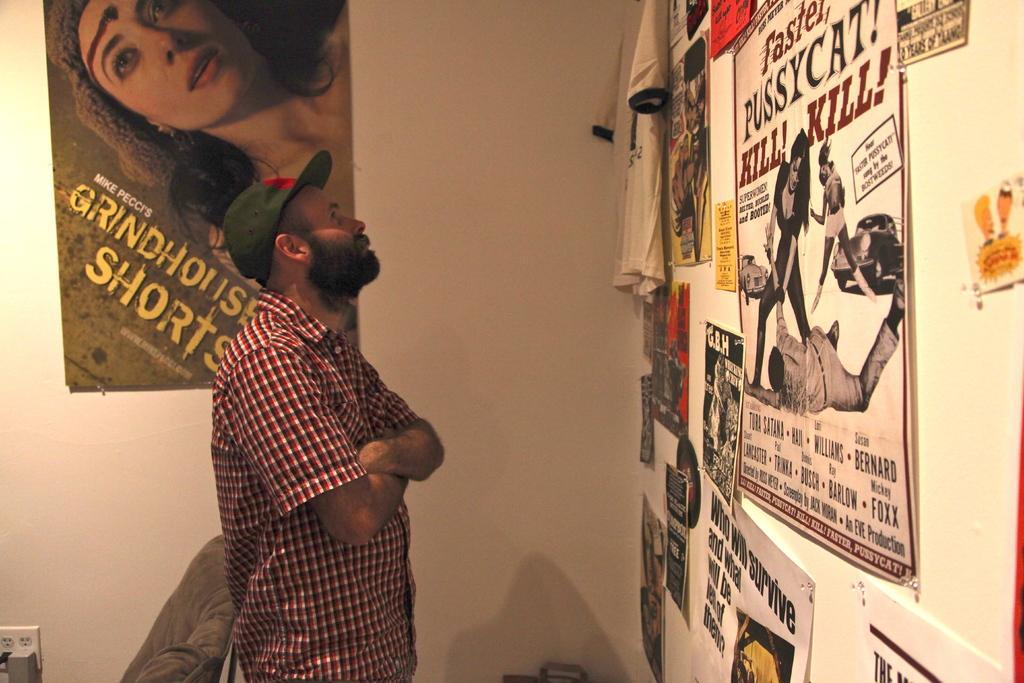Describe this image in one or two sentences. In this picture I can see a man standing. I can see a chair. There are posters and a T-shirt attached to the walls. 